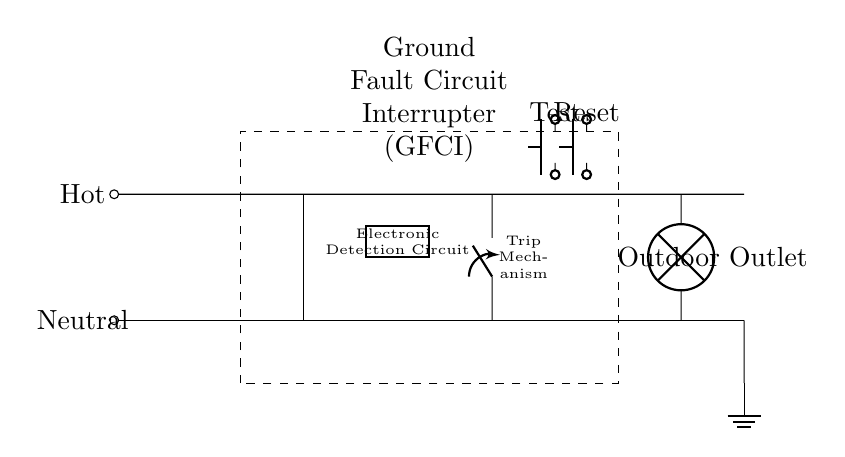What component is depicted as a dashed rectangle in the circuit? The dashed rectangle represents the Ground Fault Circuit Interrupter (GFCI), which is a protective device designed to prevent electrical shock by interrupting the circuit.
Answer: Ground Fault Circuit Interrupter (GFCI) What is the purpose of the electronic detection circuit? The electronic detection circuit detects any imbalance in the electrical current between the hot and neutral wires, which indicates a ground fault condition that may pose a safety risk.
Answer: Detection of ground faults What does the trip mechanism do in this circuit? The trip mechanism automatically opens the circuit when it detects a ground fault, cutting off the electrical supply to prevent shock and hazards.
Answer: Automatically interrupts circuit What is connected to the outlet in this circuit? A lamp is connected to the outdoor outlet, depicted as the load in the circuit diagram where the output supply is used.
Answer: Outdoor Outlet What happens when the Test button is pressed? Pressing the Test button simulates a ground fault condition, which should cause the GFCI to trip and cut power to the outlet, allowing verification of the GFCI's functionality.
Answer: Simulates ground fault condition How does the GFCI protect against electrical shocks? The GFCI monitors the current flowing through the hot and neutral wires; if it senses a difference, it indicates a potential shock hazard, leading to a quick disconnection from the power source.
Answer: Monitors current and disconnects What is the symbol for ground in this circuit? The ground is represented by the symbol at the bottom of the circuit diagram, indicating the connection to the earth which provides a reference point for the electrical system.
Answer: Ground symbol near the bottom 